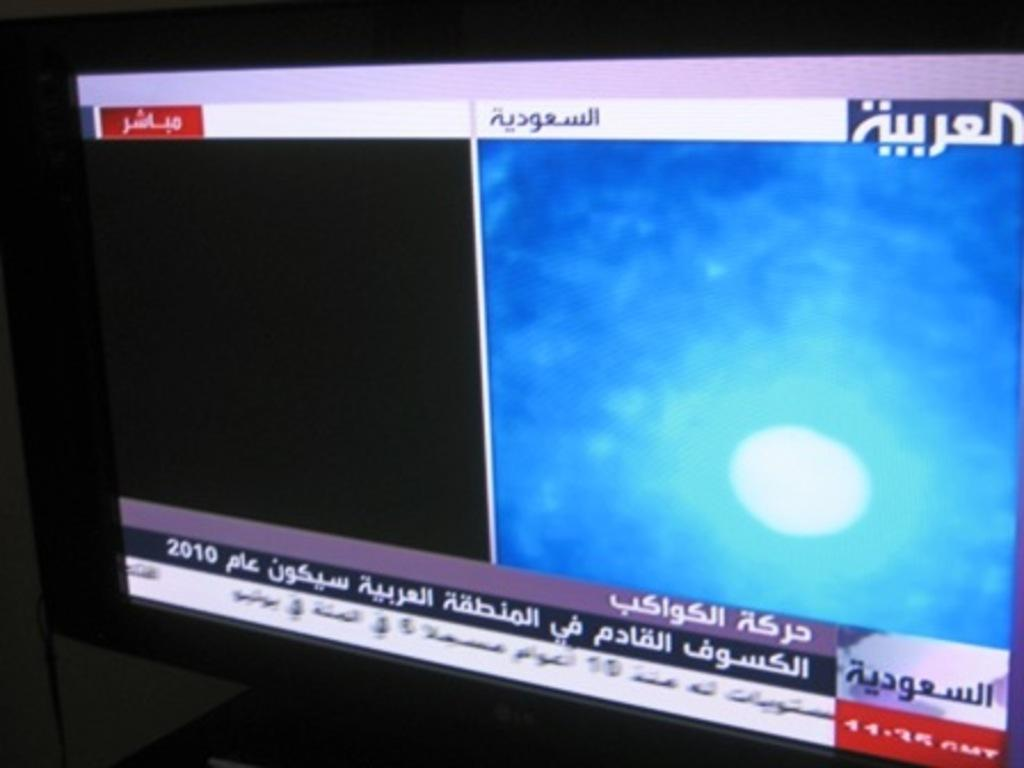<image>
Provide a brief description of the given image. A tv is displayed with a news program in a different language 